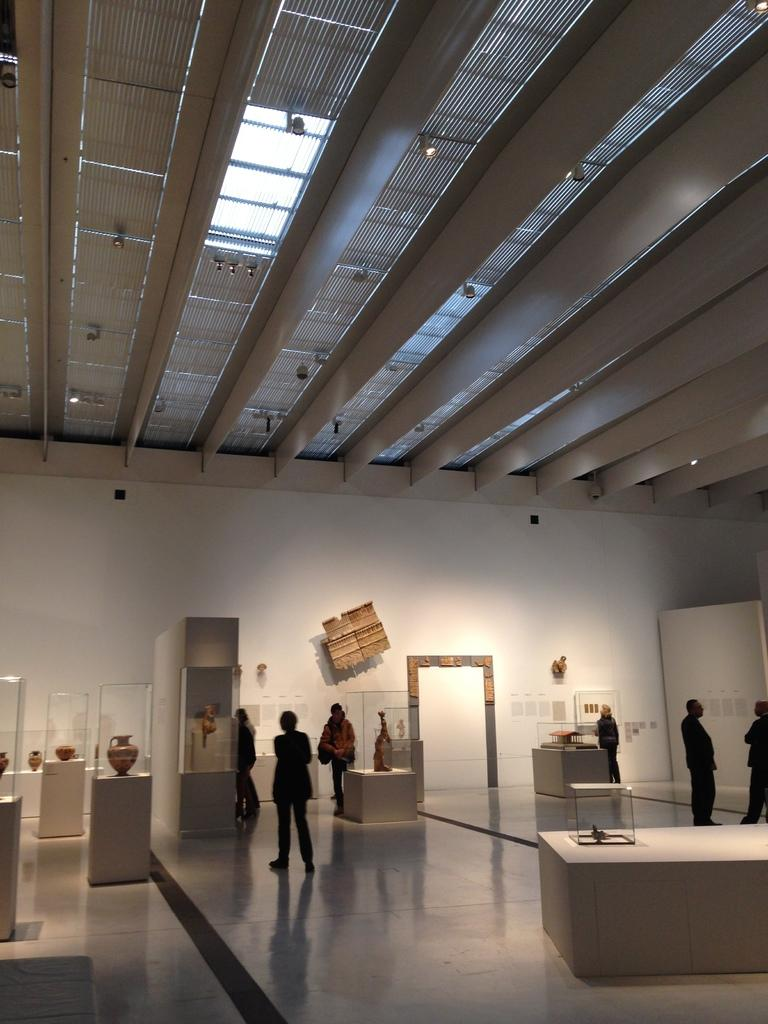What type of establishment is depicted in the image? The image contains a museum. What can be seen inside the museum? There are objects showcased in the image. Are there any visitors in the museum? Yes, there are people in the image. Where are some of the objects placed in the museum? There are objects placed on a wall in the image. How many kittens are playing with a rake in the image? There are no kittens or rakes present in the image; it features a museum with objects on display. 